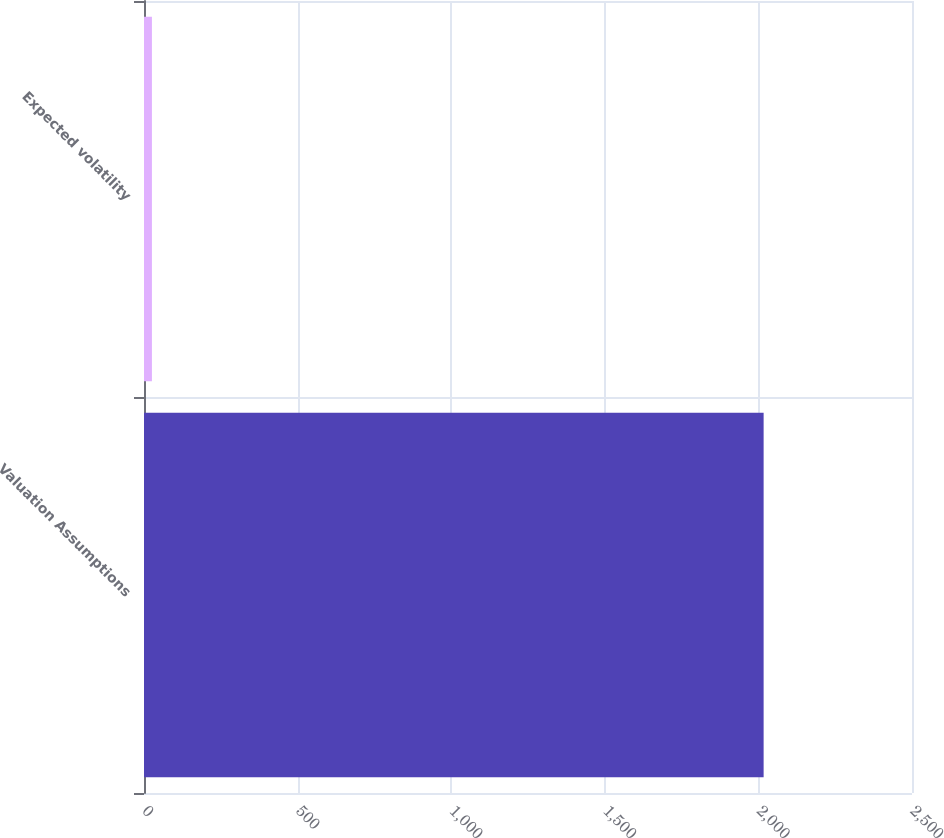Convert chart. <chart><loc_0><loc_0><loc_500><loc_500><bar_chart><fcel>Valuation Assumptions<fcel>Expected volatility<nl><fcel>2017<fcel>25.79<nl></chart> 